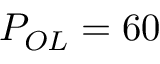Convert formula to latex. <formula><loc_0><loc_0><loc_500><loc_500>P _ { O L } = 6 0 \</formula> 